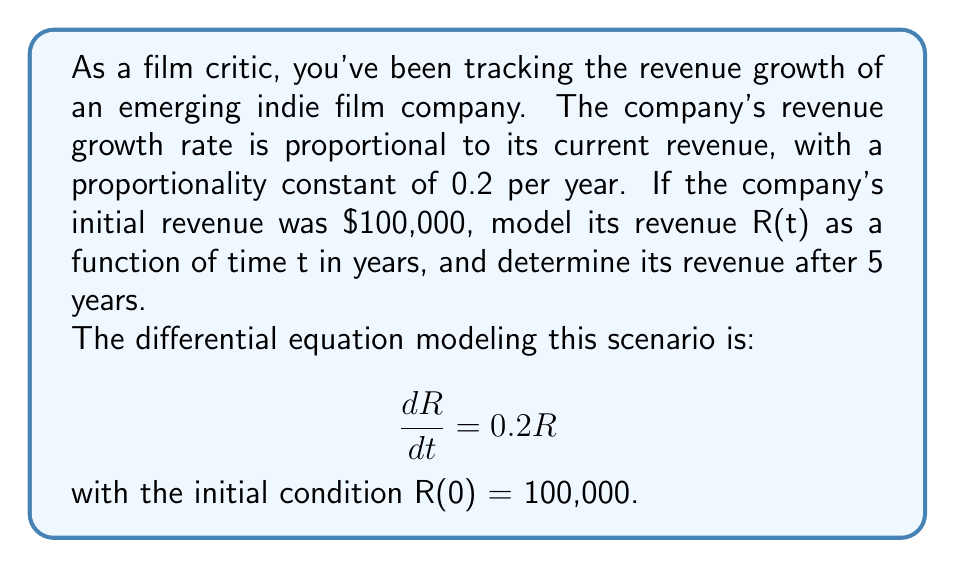Provide a solution to this math problem. 1) We start with the given differential equation:
   $$\frac{dR}{dt} = 0.2R$$

2) This is a separable first-order differential equation. We can solve it by separating variables:
   $$\frac{dR}{R} = 0.2dt$$

3) Integrate both sides:
   $$\int \frac{dR}{R} = \int 0.2dt$$
   $$\ln|R| = 0.2t + C$$

4) Exponentiate both sides:
   $$R = e^{0.2t + C} = e^C \cdot e^{0.2t}$$

5) Let $A = e^C$. Then our general solution is:
   $$R(t) = Ae^{0.2t}$$

6) Use the initial condition R(0) = 100,000 to find A:
   $$100,000 = Ae^{0 \cdot 0.2} = A$$

7) Therefore, our particular solution is:
   $$R(t) = 100,000e^{0.2t}$$

8) To find the revenue after 5 years, evaluate R(5):
   $$R(5) = 100,000e^{0.2 \cdot 5} = 100,000e^1 \approx 271,828$$

Thus, after 5 years, the company's revenue will be approximately $271,828.
Answer: $R(t) = 100,000e^{0.2t}$; $271,828 after 5 years 